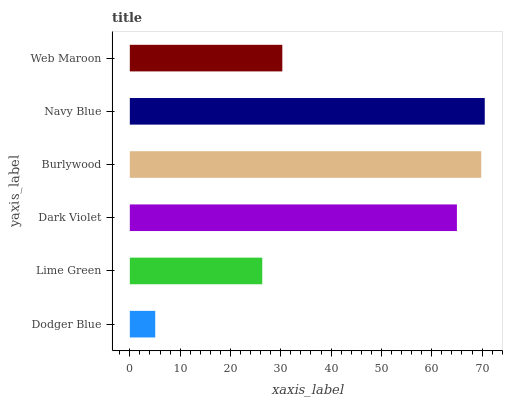Is Dodger Blue the minimum?
Answer yes or no. Yes. Is Navy Blue the maximum?
Answer yes or no. Yes. Is Lime Green the minimum?
Answer yes or no. No. Is Lime Green the maximum?
Answer yes or no. No. Is Lime Green greater than Dodger Blue?
Answer yes or no. Yes. Is Dodger Blue less than Lime Green?
Answer yes or no. Yes. Is Dodger Blue greater than Lime Green?
Answer yes or no. No. Is Lime Green less than Dodger Blue?
Answer yes or no. No. Is Dark Violet the high median?
Answer yes or no. Yes. Is Web Maroon the low median?
Answer yes or no. Yes. Is Burlywood the high median?
Answer yes or no. No. Is Dark Violet the low median?
Answer yes or no. No. 